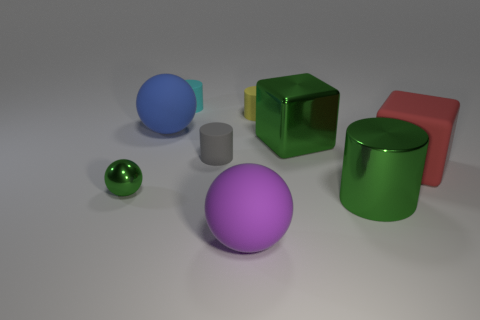What textures are visible on the objects? Most objects exhibit smooth and shiny textures that reflect the environment, indicative of materials like polished metal or plastic. The cube appears partially transparent, hinting at a glass or acrylic material with a frosted texture on one side. Can you describe the colors of the objects and what they might signify? The objects display a variety of colors: green, blue, purple, red, grey, and transparent with a greenish hue. While these are simply colors and can signify various things, they might represent diversity or a spectrum in a metaphorical context. 